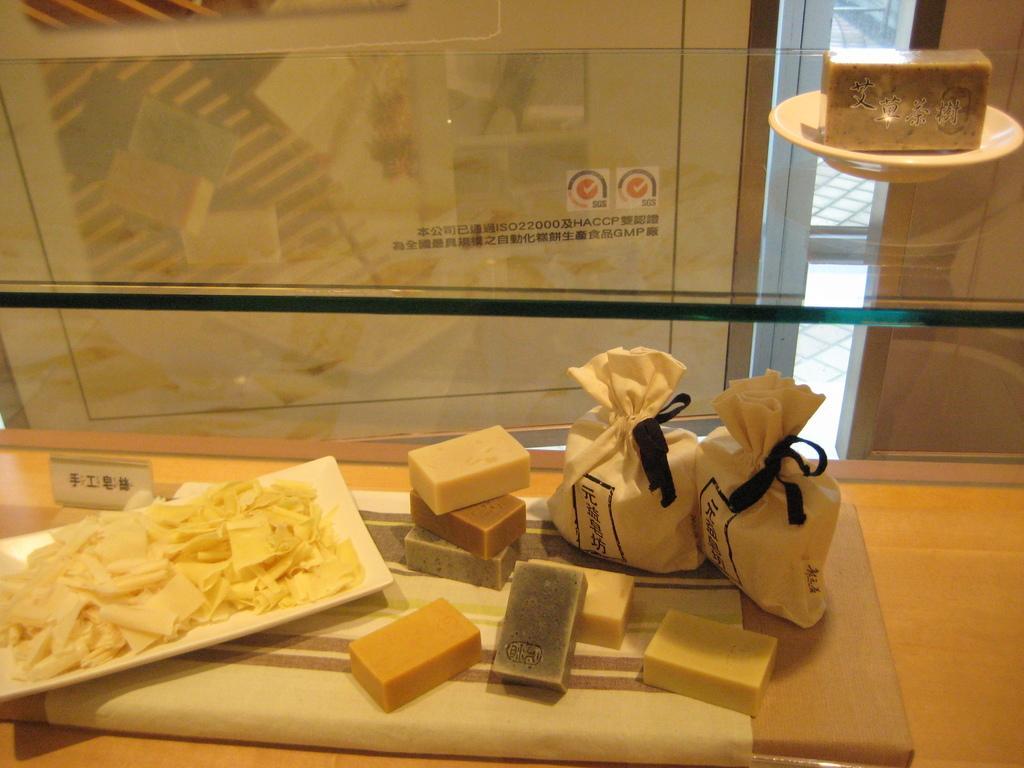Could you give a brief overview of what you see in this image? In this picture we can see a plate, a cloth, sweets and two bags present at the bottom, there is some food in this plate, we can see a glass in the middle, there is a plate present on the glass, we can see a piece of sweet in this plate. 